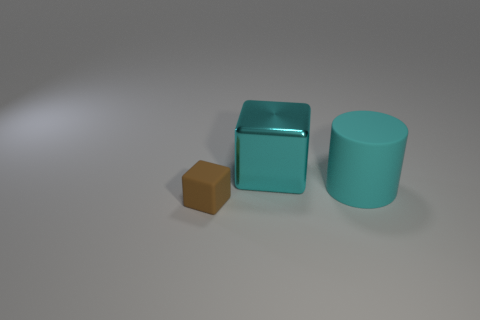What shape is the thing that is the same color as the cylinder?
Ensure brevity in your answer.  Cube. What color is the other large object that is the same shape as the brown rubber object?
Your answer should be very brief. Cyan. Is there any other thing that has the same material as the large cyan cylinder?
Offer a terse response. Yes. What is the size of the metal object that is the same shape as the small brown rubber thing?
Provide a succinct answer. Large. What is the cube that is behind the tiny brown cube made of?
Offer a very short reply. Metal. Are there fewer cyan cylinders that are to the right of the cyan cylinder than big yellow cubes?
Offer a very short reply. No. There is a rubber thing that is left of the big cyan object on the left side of the large cylinder; what shape is it?
Offer a very short reply. Cube. What is the color of the rubber block?
Provide a succinct answer. Brown. What number of other things are there of the same size as the cyan metal block?
Give a very brief answer. 1. What is the thing that is in front of the cyan shiny thing and behind the rubber block made of?
Your answer should be very brief. Rubber. 